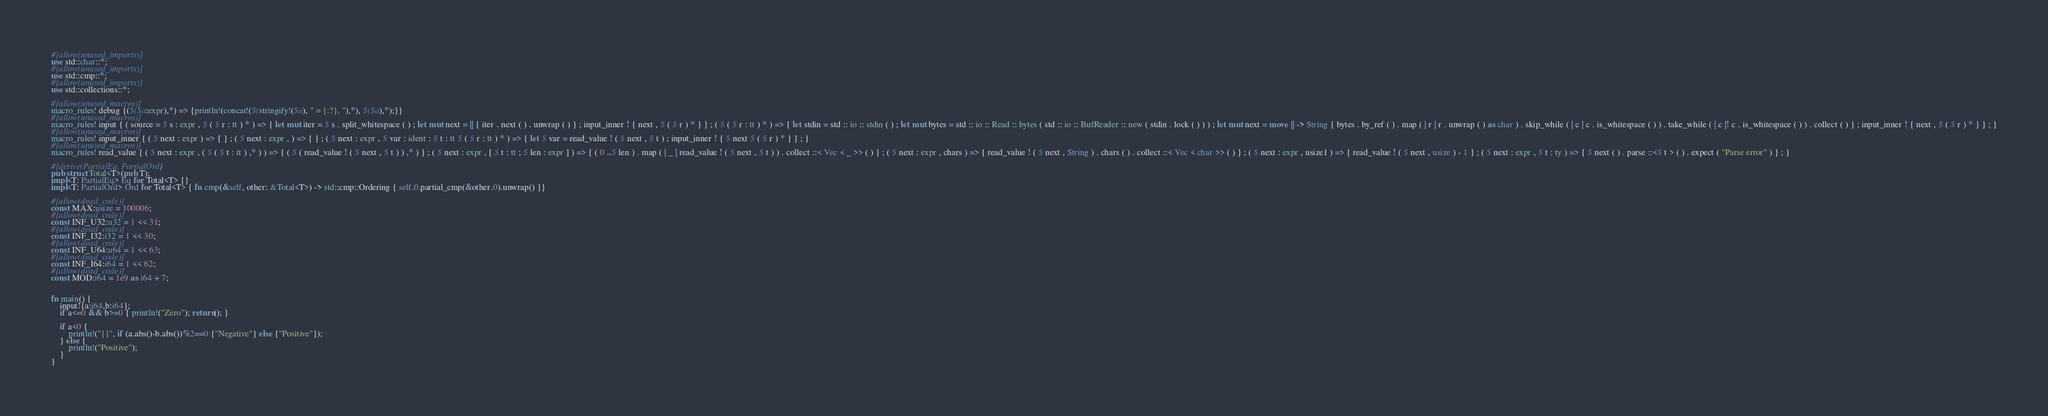Convert code to text. <code><loc_0><loc_0><loc_500><loc_500><_Rust_>#[allow(unused_imports)]
use std::char::*;
#[allow(unused_imports)]
use std::cmp::*;
#[allow(unused_imports)]
use std::collections::*;

#[allow(unused_macros)]
macro_rules! debug {($($a:expr),*) => {println!(concat!($(stringify!($a), " = {:?}, "),*), $($a),*);}}
#[allow(unused_macros)]
macro_rules! input { ( source = $ s : expr , $ ( $ r : tt ) * ) => { let mut iter = $ s . split_whitespace ( ) ; let mut next = || { iter . next ( ) . unwrap ( ) } ; input_inner ! { next , $ ( $ r ) * } } ; ( $ ( $ r : tt ) * ) => { let stdin = std :: io :: stdin ( ) ; let mut bytes = std :: io :: Read :: bytes ( std :: io :: BufReader :: new ( stdin . lock ( ) ) ) ; let mut next = move || -> String { bytes . by_ref ( ) . map ( | r | r . unwrap ( ) as char ) . skip_while ( | c | c . is_whitespace ( ) ) . take_while ( | c |! c . is_whitespace ( ) ) . collect ( ) } ; input_inner ! { next , $ ( $ r ) * } } ; }
#[allow(unused_macros)]
macro_rules! input_inner { ( $ next : expr ) => { } ; ( $ next : expr , ) => { } ; ( $ next : expr , $ var : ident : $ t : tt $ ( $ r : tt ) * ) => { let $ var = read_value ! ( $ next , $ t ) ; input_inner ! { $ next $ ( $ r ) * } } ; }
#[allow(unused_macros)]
macro_rules! read_value { ( $ next : expr , ( $ ( $ t : tt ) ,* ) ) => { ( $ ( read_value ! ( $ next , $ t ) ) ,* ) } ; ( $ next : expr , [ $ t : tt ; $ len : expr ] ) => { ( 0 ..$ len ) . map ( | _ | read_value ! ( $ next , $ t ) ) . collect ::< Vec < _ >> ( ) } ; ( $ next : expr , chars ) => { read_value ! ( $ next , String ) . chars ( ) . collect ::< Vec < char >> ( ) } ; ( $ next : expr , usize1 ) => { read_value ! ( $ next , usize ) - 1 } ; ( $ next : expr , $ t : ty ) => { $ next ( ) . parse ::<$ t > ( ) . expect ( "Parse error" ) } ; }

#[derive(PartialEq, PartialOrd)]
pub struct Total<T>(pub T);
impl<T: PartialEq> Eq for Total<T> {}
impl<T: PartialOrd> Ord for Total<T> { fn cmp(&self, other: &Total<T>) -> std::cmp::Ordering { self.0.partial_cmp(&other.0).unwrap() }}

#[allow(dead_code)]
const MAX:usize = 100006;
#[allow(dead_code)]
const INF_U32:u32 = 1 << 31;
#[allow(dead_code)]
const INF_I32:i32 = 1 << 30;
#[allow(dead_code)]
const INF_U64:u64 = 1 << 63;
#[allow(dead_code)]
const INF_I64:i64 = 1 << 62;
#[allow(dead_code)]
const MOD:i64 = 1e9 as i64 + 7;


fn main() {
    input!{a:i64,b:i64};
    if a<=0 && b>=0 { println!("Zero"); return(); }

    if a<0 {
        println!("{}", if (a.abs()-b.abs())%2==0 {"Negative"} else {"Positive"});
    } else {
        println!("Positive");
    }
}</code> 